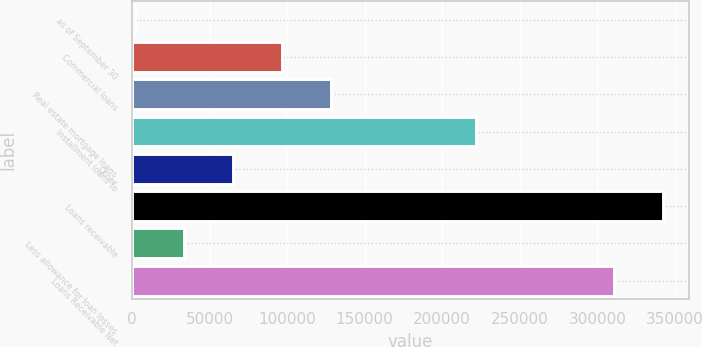Convert chart. <chart><loc_0><loc_0><loc_500><loc_500><bar_chart><fcel>as of September 30<fcel>Commercial loans<fcel>Real estate mortgage loans<fcel>Installment loans to<fcel>Other<fcel>Loans receivable<fcel>Less allowance for loan losses<fcel>Loans Receivable Net<nl><fcel>2009<fcel>96665.3<fcel>128217<fcel>221765<fcel>65113.2<fcel>342056<fcel>33561.1<fcel>310504<nl></chart> 